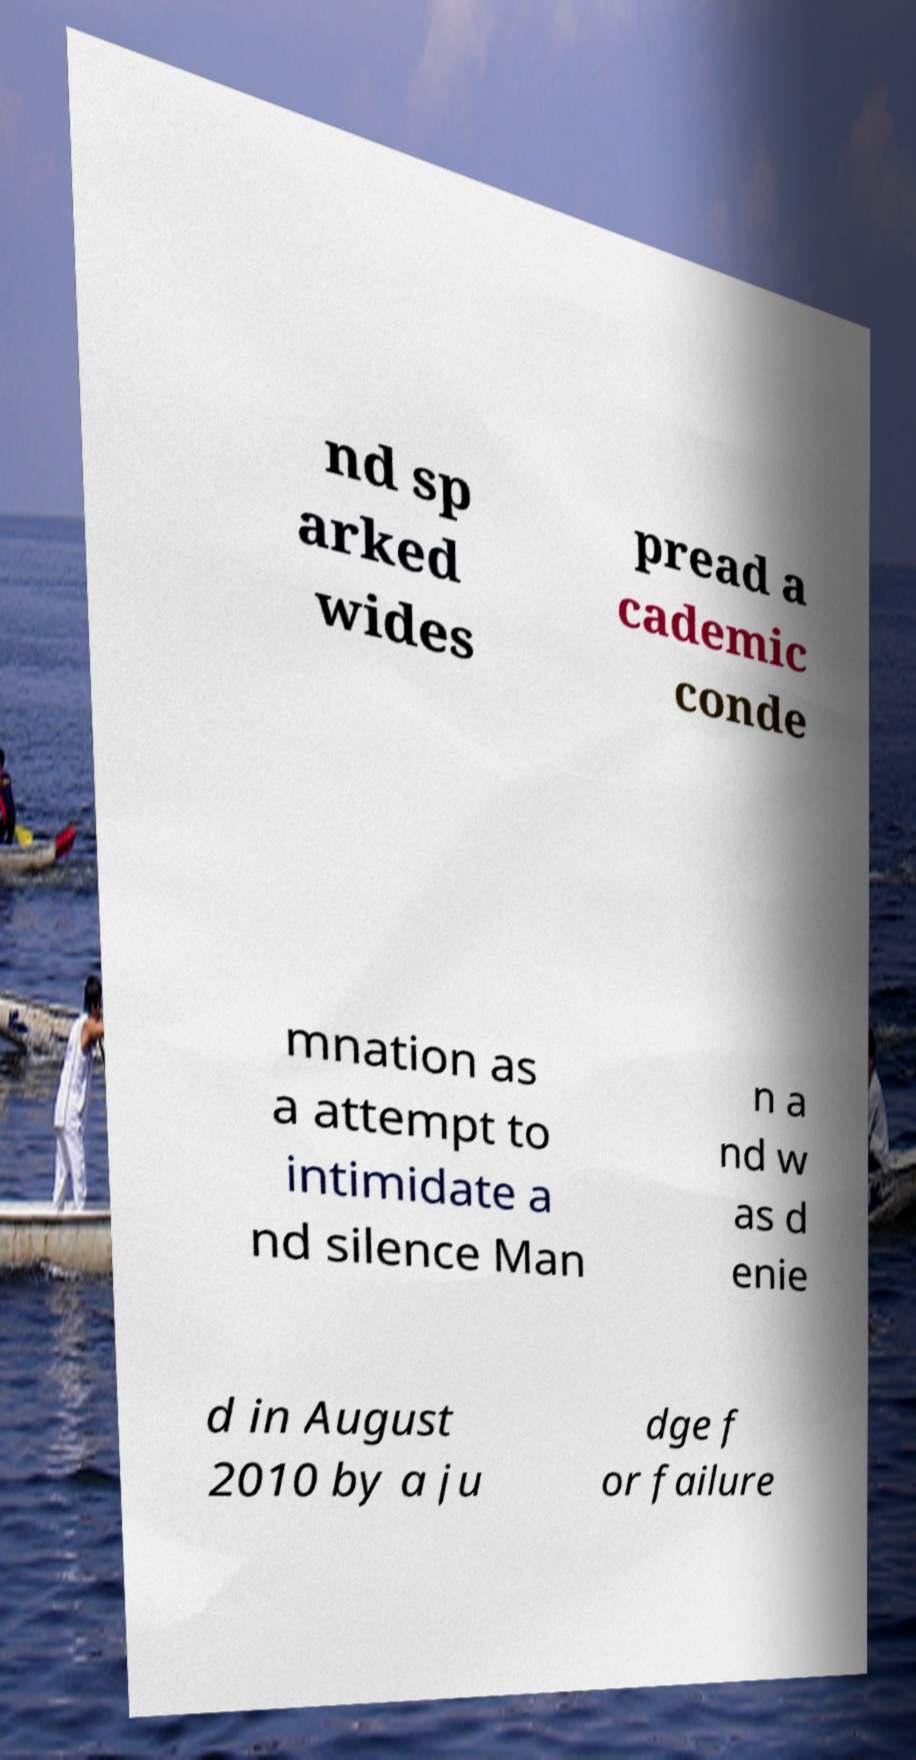Could you assist in decoding the text presented in this image and type it out clearly? nd sp arked wides pread a cademic conde mnation as a attempt to intimidate a nd silence Man n a nd w as d enie d in August 2010 by a ju dge f or failure 